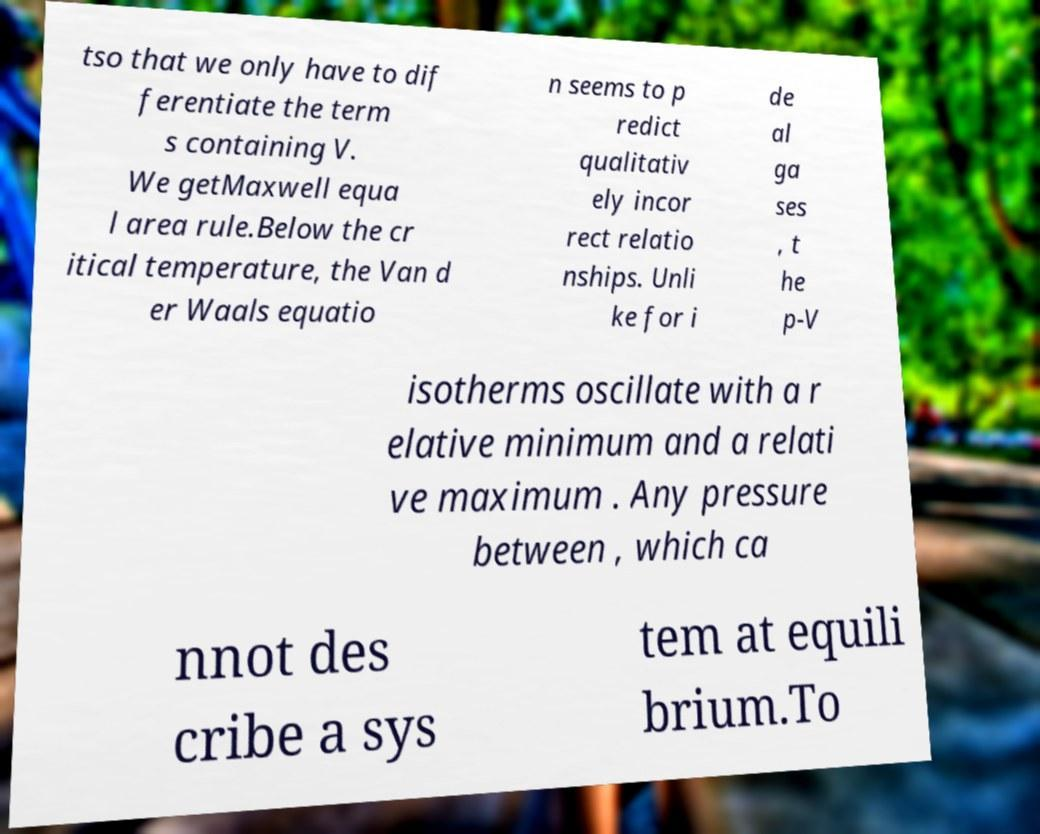Could you assist in decoding the text presented in this image and type it out clearly? tso that we only have to dif ferentiate the term s containing V. We getMaxwell equa l area rule.Below the cr itical temperature, the Van d er Waals equatio n seems to p redict qualitativ ely incor rect relatio nships. Unli ke for i de al ga ses , t he p-V isotherms oscillate with a r elative minimum and a relati ve maximum . Any pressure between , which ca nnot des cribe a sys tem at equili brium.To 